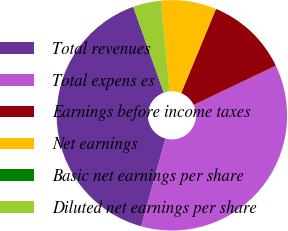Convert chart. <chart><loc_0><loc_0><loc_500><loc_500><pie_chart><fcel>Total revenues<fcel>Total expens es<fcel>Earnings before income taxes<fcel>Net earnings<fcel>Basic net earnings per share<fcel>Diluted net earnings per share<nl><fcel>40.26%<fcel>36.38%<fcel>11.66%<fcel>7.78%<fcel>0.02%<fcel>3.9%<nl></chart> 